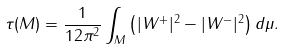<formula> <loc_0><loc_0><loc_500><loc_500>\tau ( M ) = \frac { 1 } { 1 2 \pi ^ { 2 } } \int _ { M } \left ( | W ^ { + } | ^ { 2 } - | W ^ { - } | ^ { 2 } \right ) d \mu .</formula> 